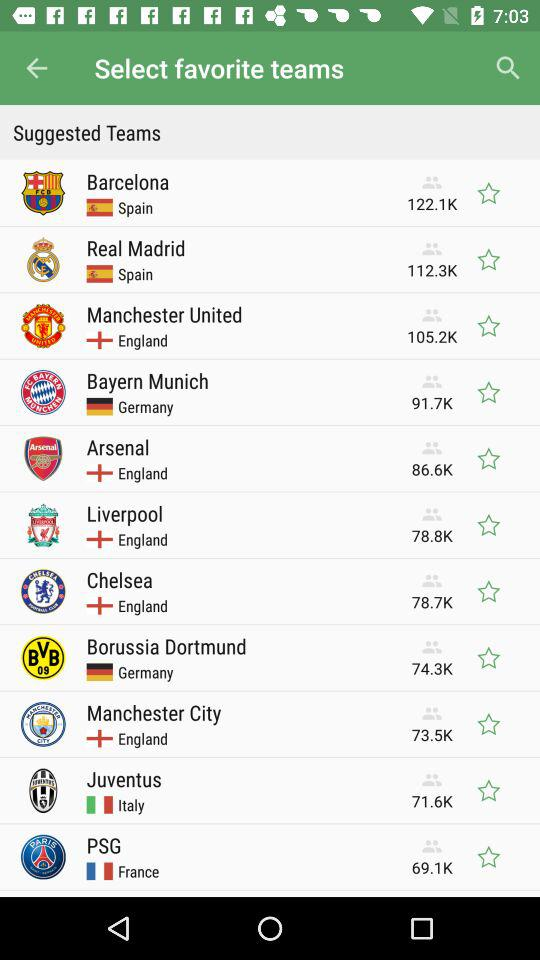How many followers are there for "Chelsea"? There are 78.7K followers. 